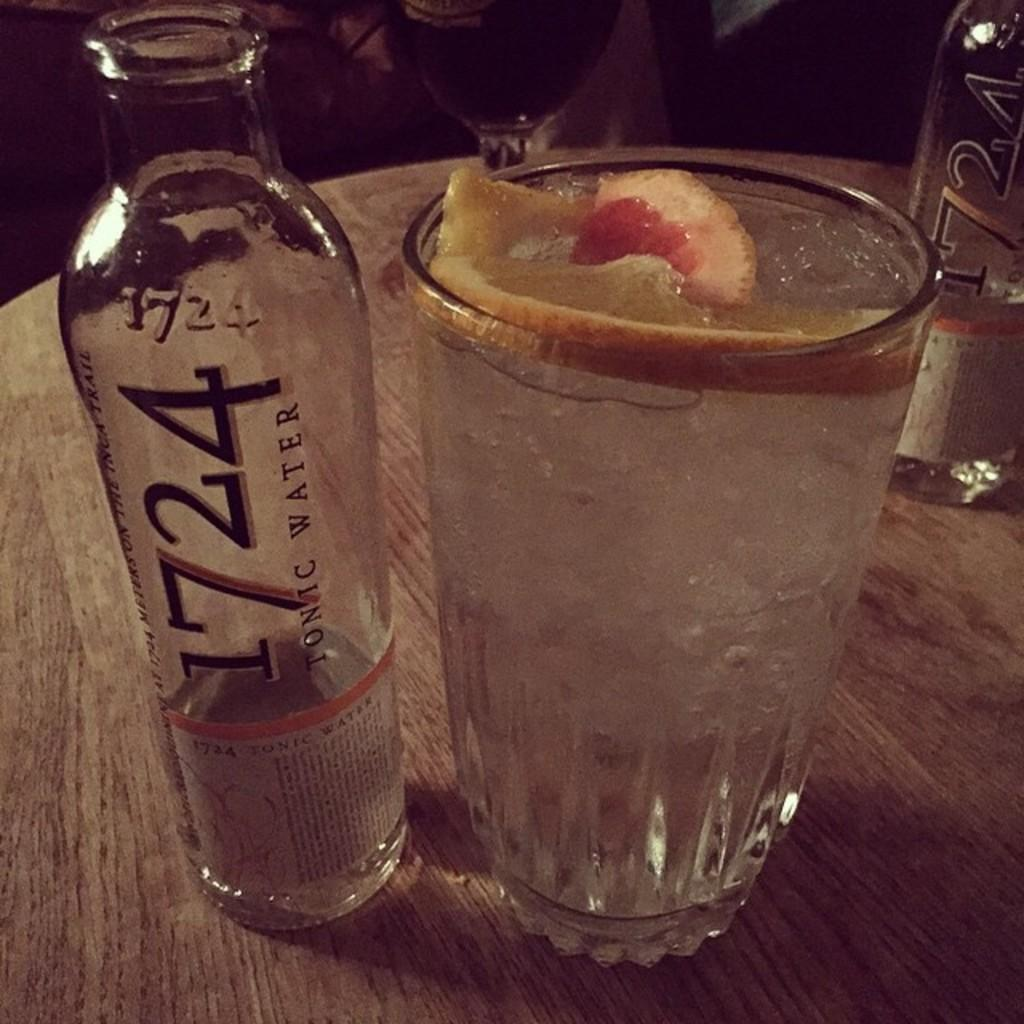Provide a one-sentence caption for the provided image. A clear bottle with 724 next to a glass. 